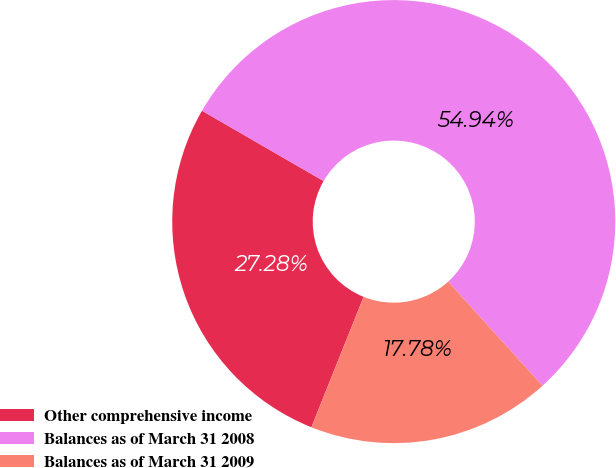Convert chart. <chart><loc_0><loc_0><loc_500><loc_500><pie_chart><fcel>Other comprehensive income<fcel>Balances as of March 31 2008<fcel>Balances as of March 31 2009<nl><fcel>27.28%<fcel>54.94%<fcel>17.78%<nl></chart> 